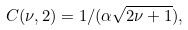Convert formula to latex. <formula><loc_0><loc_0><loc_500><loc_500>C ( \nu , 2 ) = 1 / ( \alpha \sqrt { 2 \nu + 1 } ) ,</formula> 